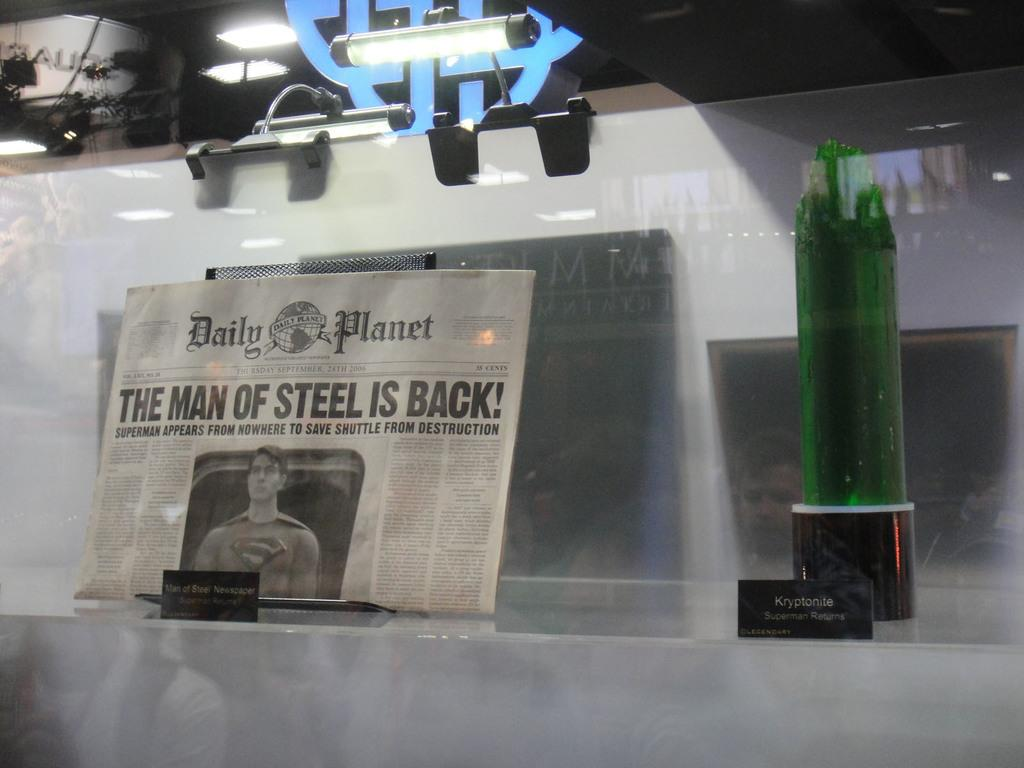What is the main object in the image? There is a whiteboard in the image. What is placed on the whiteboard? There is a newspaper on the whiteboard. What does the newspaper headline say? The newspaper headline reads "THE MAN OF STEEL IS BACK." What type of lighting is present above the whiteboard? There are lights on top of the whiteboard. What else can be seen in the image besides the whiteboard and newspaper? There is a bottle in the image. What type of stone is used to create the love crib in the image? There is no stone or love crib present in the image; it features a whiteboard with a newspaper and lights. 